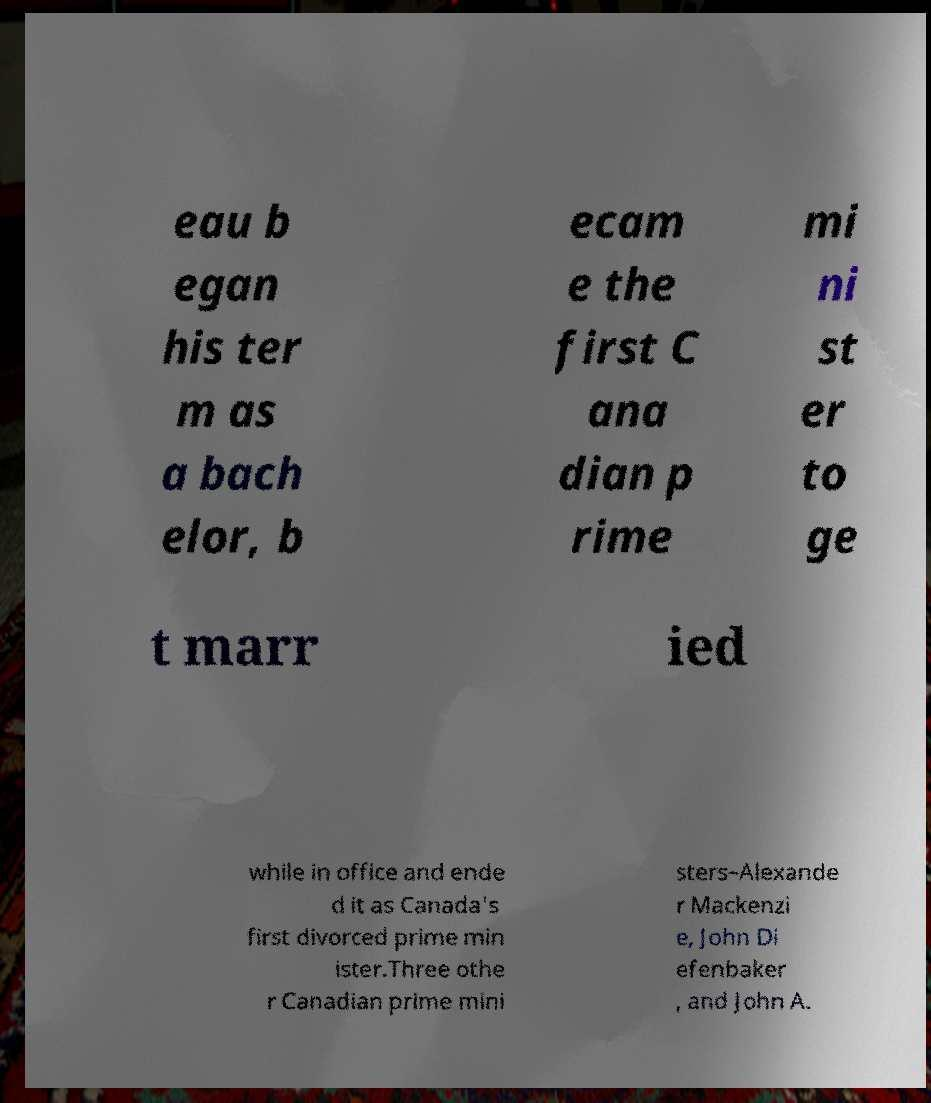Can you read and provide the text displayed in the image?This photo seems to have some interesting text. Can you extract and type it out for me? eau b egan his ter m as a bach elor, b ecam e the first C ana dian p rime mi ni st er to ge t marr ied while in office and ende d it as Canada's first divorced prime min ister.Three othe r Canadian prime mini sters–Alexande r Mackenzi e, John Di efenbaker , and John A. 